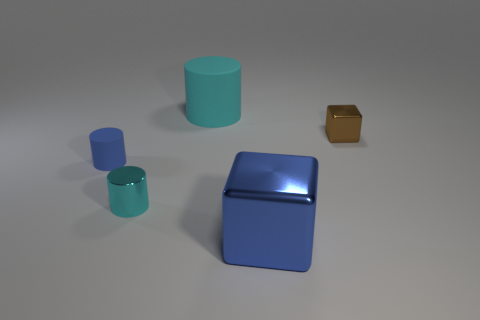How many objects are either tiny shiny things or cyan cylinders that are left of the large cyan rubber thing?
Provide a short and direct response. 2. Is there a shiny object that is to the left of the object on the right side of the blue shiny thing?
Offer a very short reply. Yes. The tiny thing that is to the right of the cyan rubber object is what color?
Your answer should be compact. Brown. Is the number of tiny metal objects that are in front of the blue rubber cylinder the same as the number of large brown metallic spheres?
Ensure brevity in your answer.  No. There is a metallic thing that is in front of the tiny shiny cube and right of the big cyan matte cylinder; what shape is it?
Your answer should be very brief. Cube. There is another large thing that is the same shape as the brown thing; what color is it?
Give a very brief answer. Blue. Are there any other things that are the same color as the large metallic block?
Your response must be concise. Yes. There is a large object that is behind the blue object on the right side of the cyan cylinder in front of the cyan matte cylinder; what is its shape?
Keep it short and to the point. Cylinder. Do the rubber cylinder in front of the brown shiny thing and the metal cube that is behind the blue matte cylinder have the same size?
Make the answer very short. Yes. How many other blue objects have the same material as the small blue thing?
Provide a succinct answer. 0. 